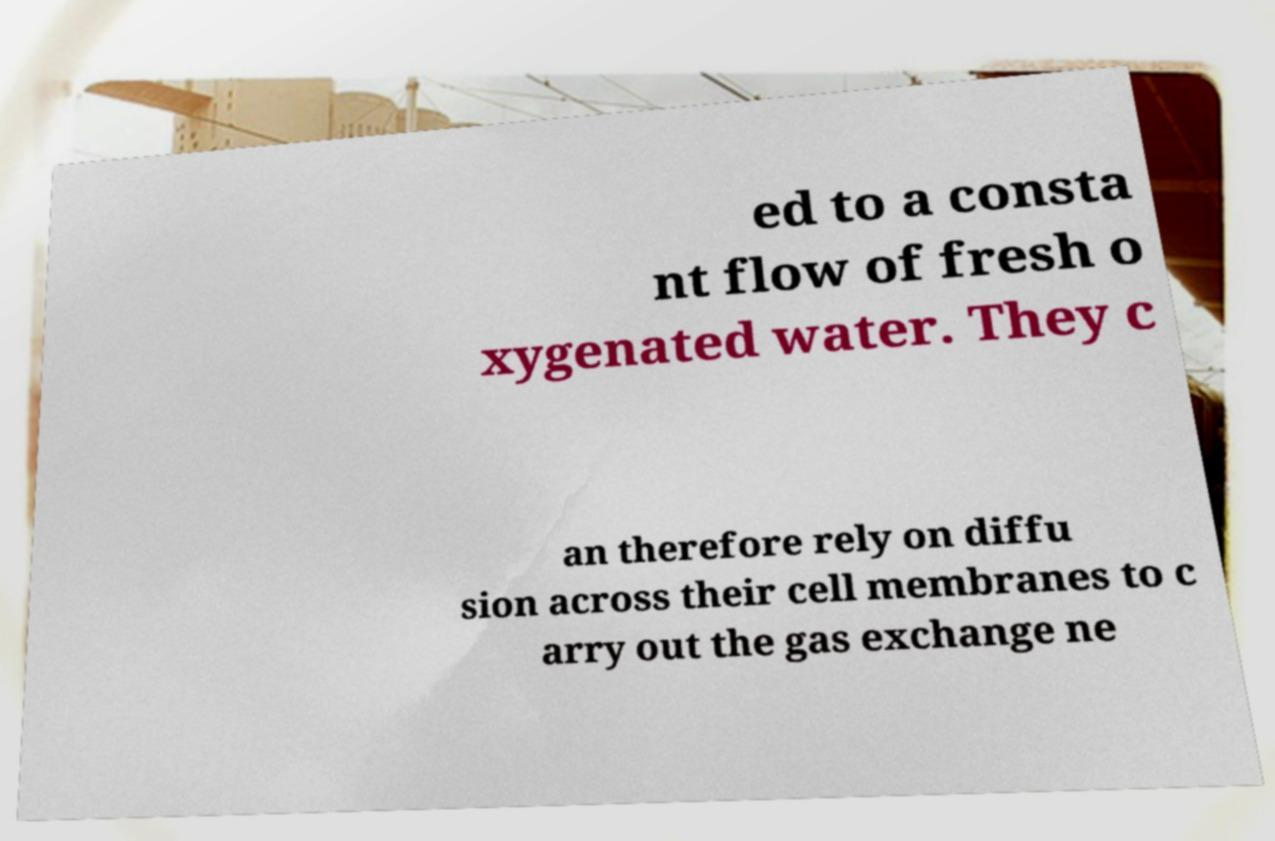I need the written content from this picture converted into text. Can you do that? ed to a consta nt flow of fresh o xygenated water. They c an therefore rely on diffu sion across their cell membranes to c arry out the gas exchange ne 